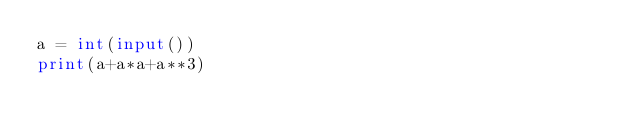Convert code to text. <code><loc_0><loc_0><loc_500><loc_500><_Python_>a = int(input())
print(a+a*a+a**3)</code> 